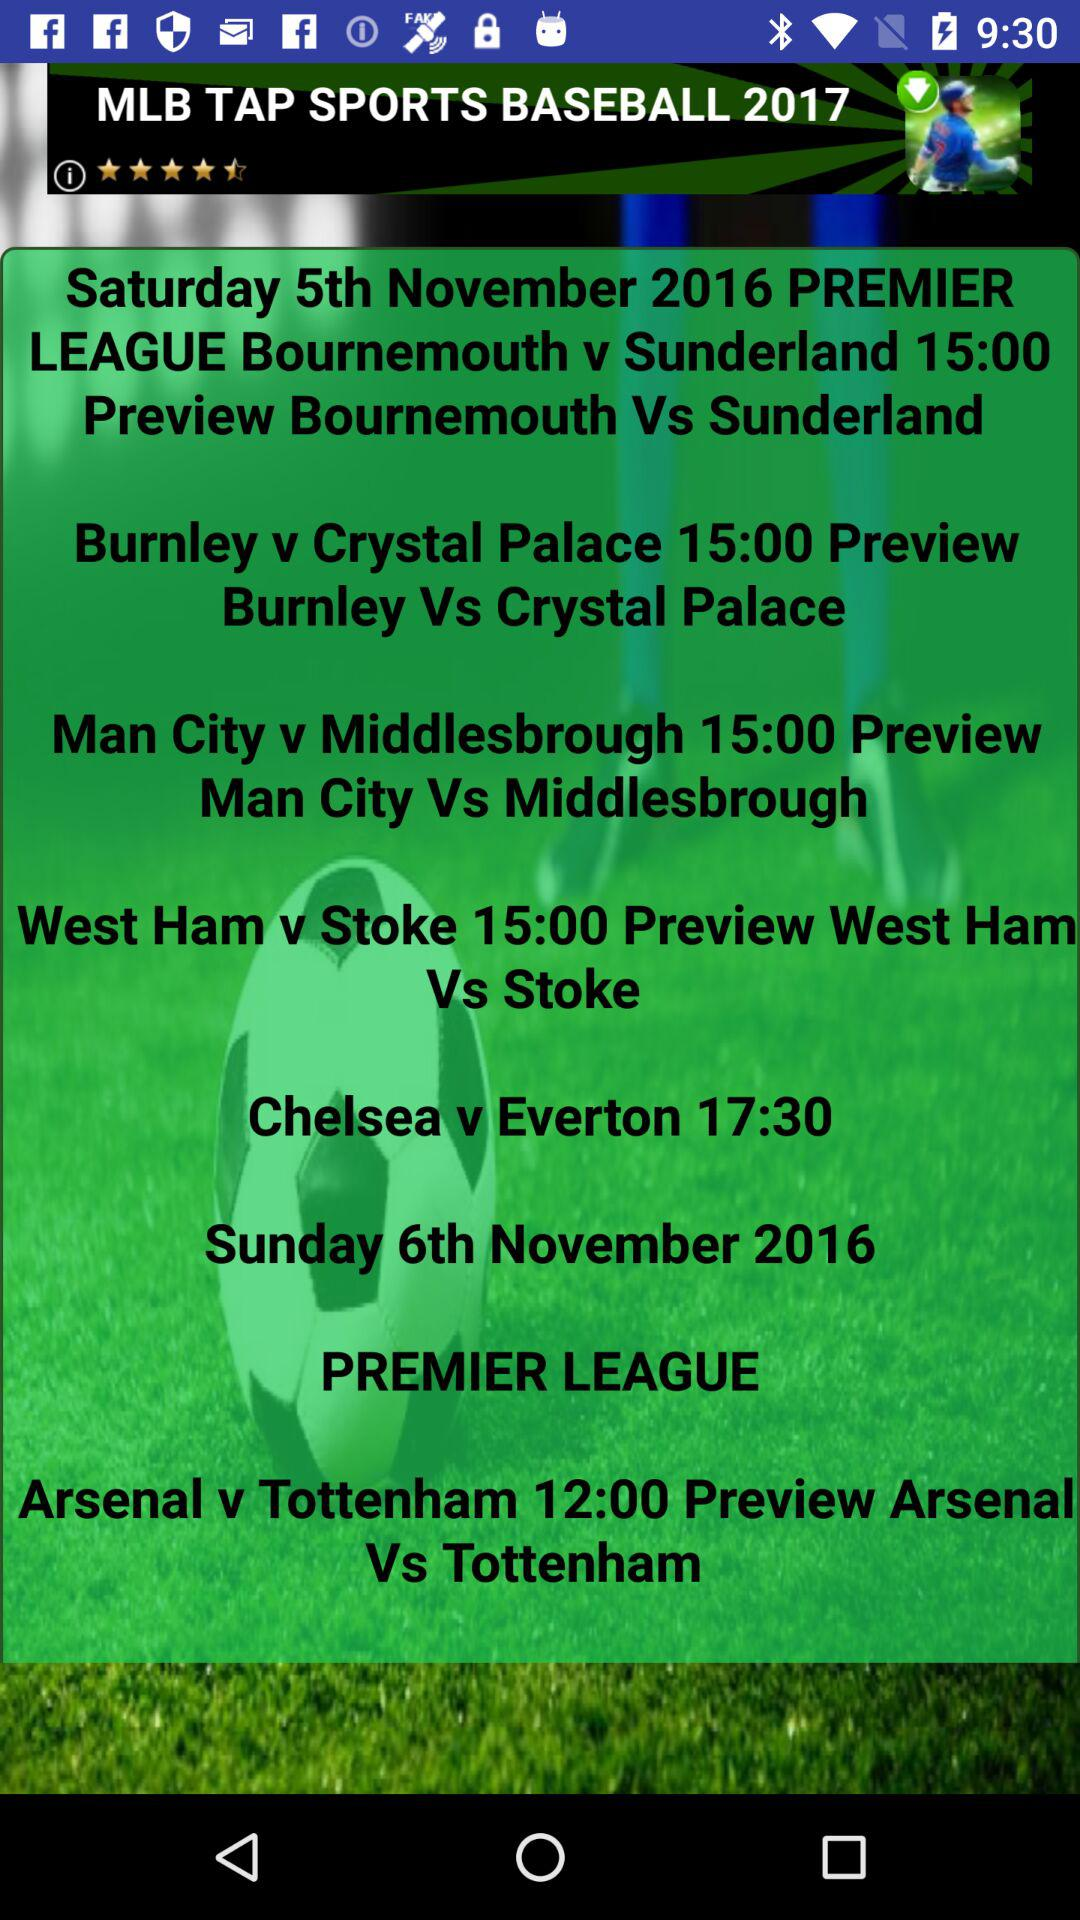What is the date of the Premier League of Bournemouth v Sunderland? The date is Saturday, November 5, 2016. 